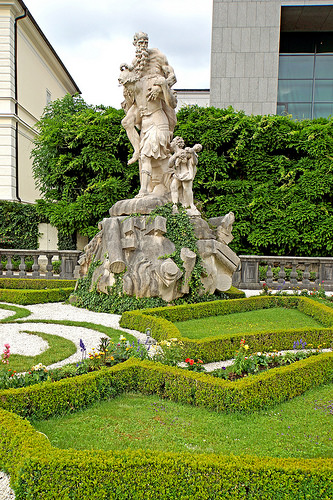<image>
Can you confirm if the grass is behind the building? Yes. From this viewpoint, the grass is positioned behind the building, with the building partially or fully occluding the grass. Where is the hedge in relation to the statue? Is it under the statue? Yes. The hedge is positioned underneath the statue, with the statue above it in the vertical space. 